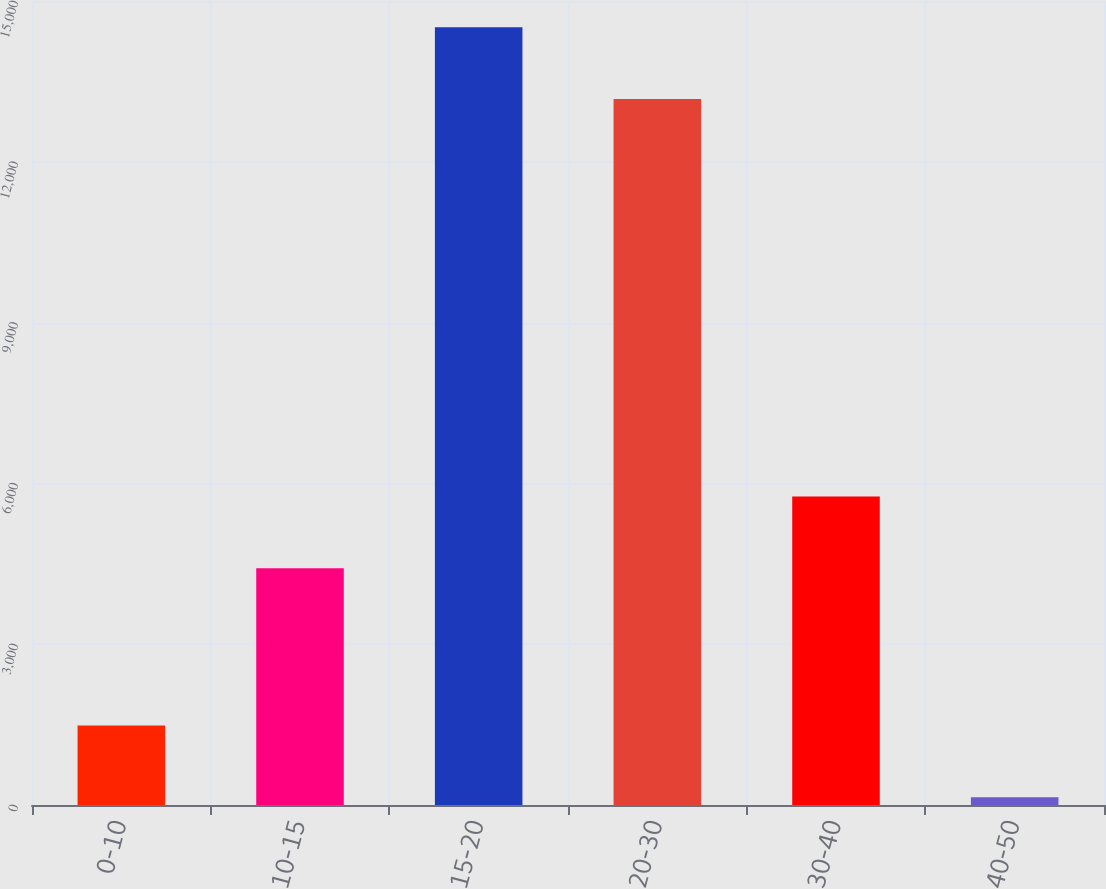<chart> <loc_0><loc_0><loc_500><loc_500><bar_chart><fcel>0-10<fcel>10-15<fcel>15-20<fcel>20-30<fcel>30-40<fcel>40-50<nl><fcel>1483.2<fcel>4418<fcel>14511.2<fcel>13172<fcel>5757.2<fcel>144<nl></chart> 